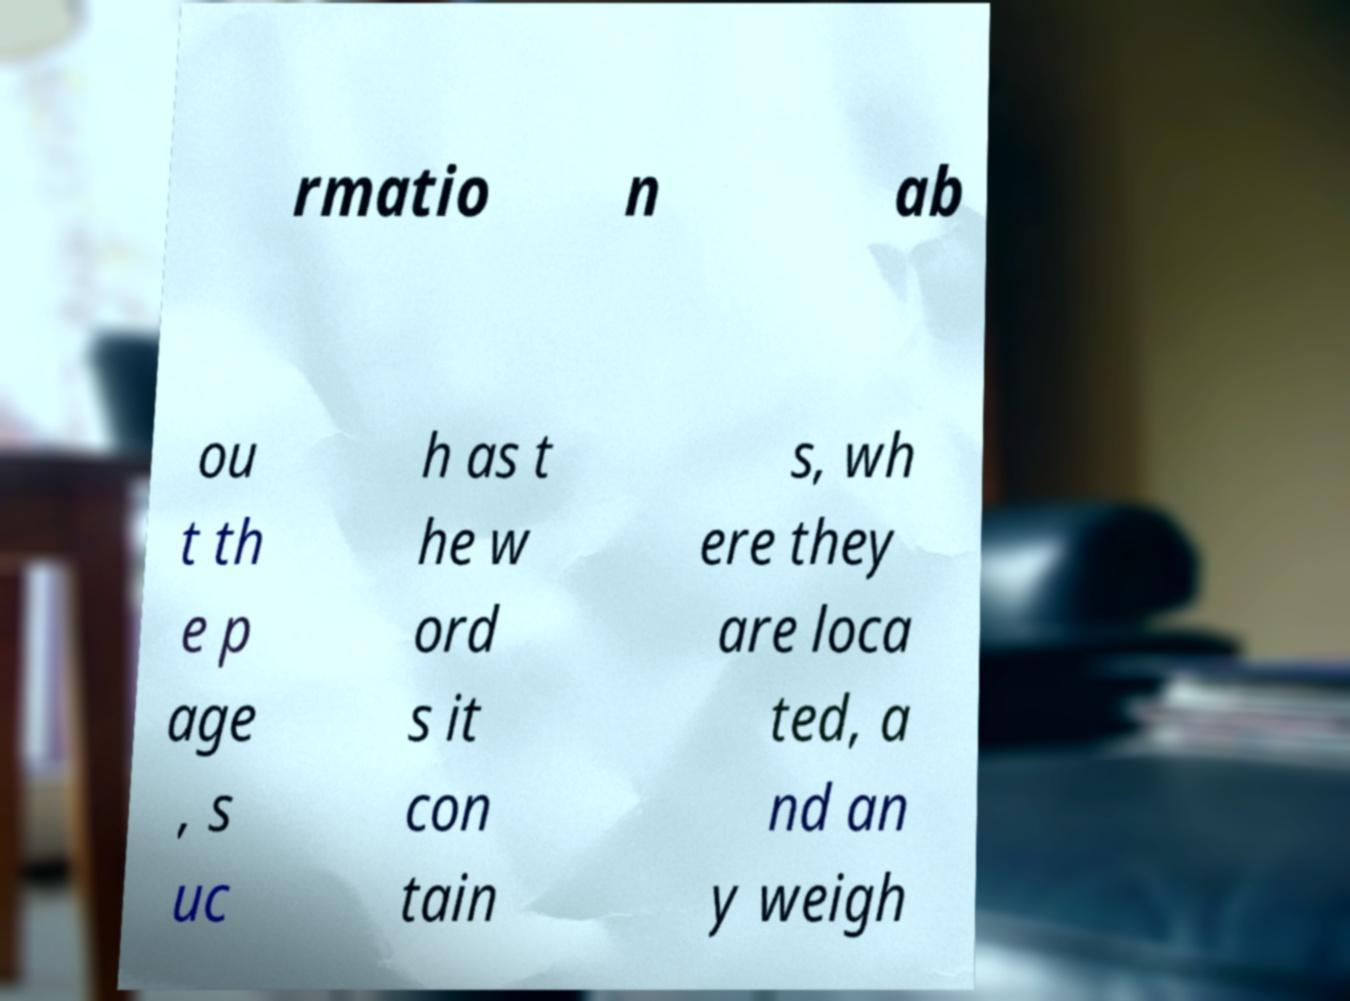There's text embedded in this image that I need extracted. Can you transcribe it verbatim? rmatio n ab ou t th e p age , s uc h as t he w ord s it con tain s, wh ere they are loca ted, a nd an y weigh 